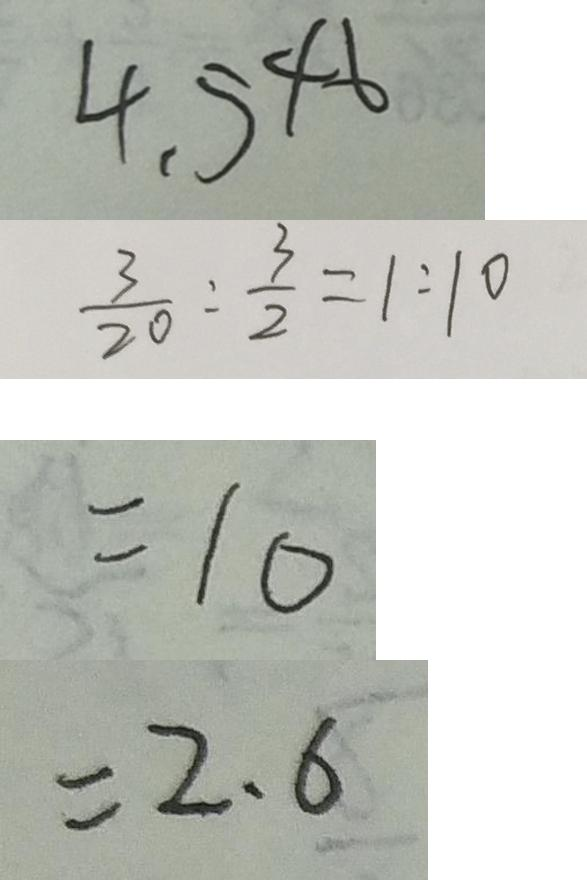<formula> <loc_0><loc_0><loc_500><loc_500>4 . 5 4 6 
 \frac { 3 } { 2 0 } : \frac { 3 } { 2 } = 1 : 1 0 
 = 1 0 
 = 2 . 6</formula> 